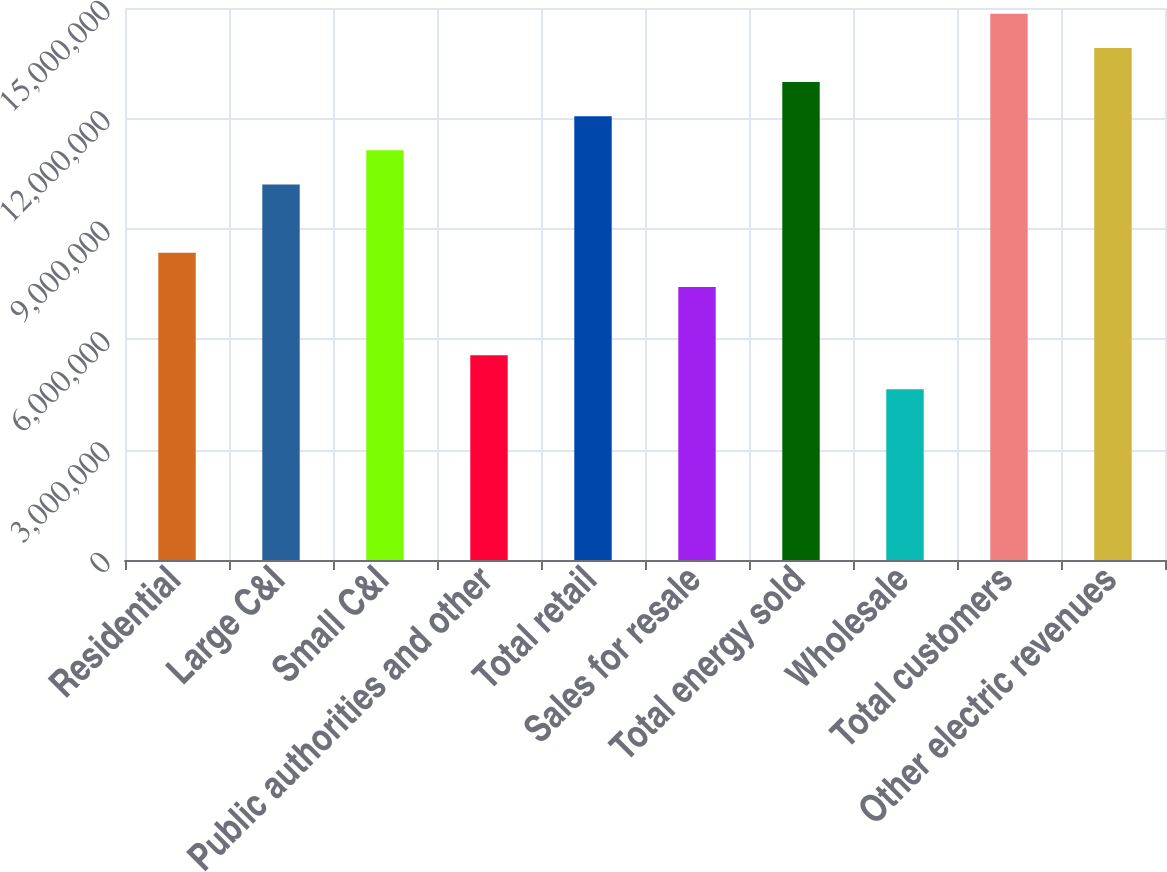<chart> <loc_0><loc_0><loc_500><loc_500><bar_chart><fcel>Residential<fcel>Large C&I<fcel>Small C&I<fcel>Public authorities and other<fcel>Total retail<fcel>Sales for resale<fcel>Total energy sold<fcel>Wholesale<fcel>Total customers<fcel>Other electric revenues<nl><fcel>8.34839e+06<fcel>1.02036e+07<fcel>1.11312e+07<fcel>5.56559e+06<fcel>1.20588e+07<fcel>7.42079e+06<fcel>1.29864e+07<fcel>4.638e+06<fcel>1.48416e+07<fcel>1.3914e+07<nl></chart> 